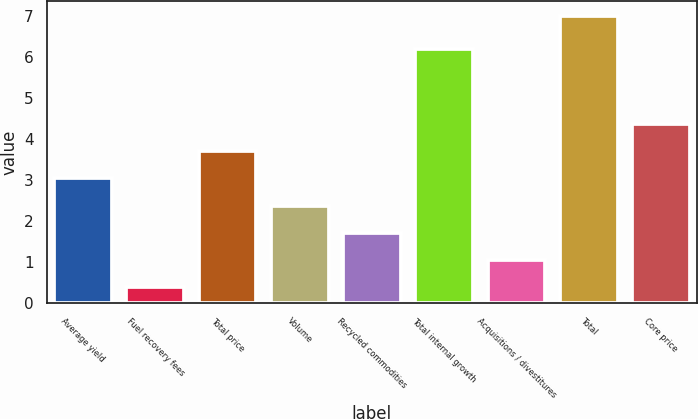Convert chart to OTSL. <chart><loc_0><loc_0><loc_500><loc_500><bar_chart><fcel>Average yield<fcel>Fuel recovery fees<fcel>Total price<fcel>Volume<fcel>Recycled commodities<fcel>Total internal growth<fcel>Acquisitions / divestitures<fcel>Total<fcel>Core price<nl><fcel>3.04<fcel>0.4<fcel>3.7<fcel>2.38<fcel>1.72<fcel>6.2<fcel>1.06<fcel>7<fcel>4.36<nl></chart> 